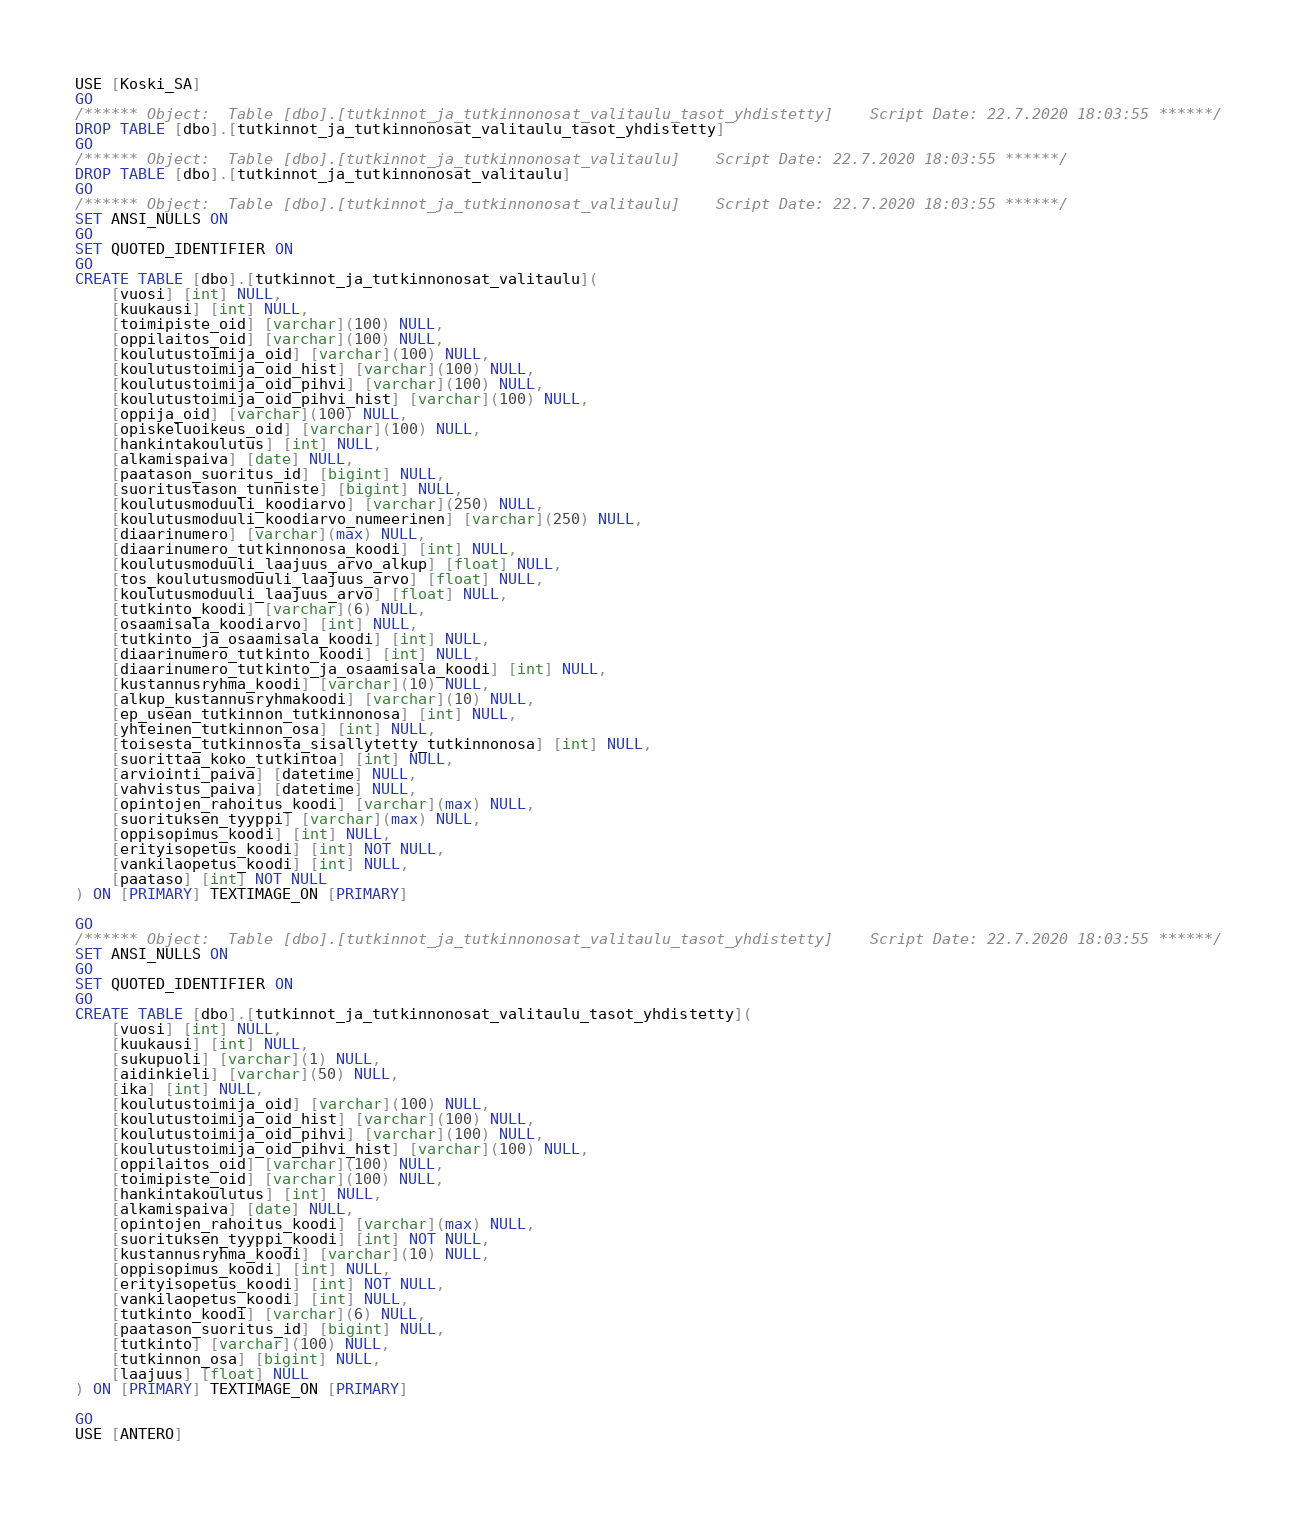Convert code to text. <code><loc_0><loc_0><loc_500><loc_500><_SQL_>USE [Koski_SA]
GO
/****** Object:  Table [dbo].[tutkinnot_ja_tutkinnonosat_valitaulu_tasot_yhdistetty]    Script Date: 22.7.2020 18:03:55 ******/
DROP TABLE [dbo].[tutkinnot_ja_tutkinnonosat_valitaulu_tasot_yhdistetty]
GO
/****** Object:  Table [dbo].[tutkinnot_ja_tutkinnonosat_valitaulu]    Script Date: 22.7.2020 18:03:55 ******/
DROP TABLE [dbo].[tutkinnot_ja_tutkinnonosat_valitaulu]
GO
/****** Object:  Table [dbo].[tutkinnot_ja_tutkinnonosat_valitaulu]    Script Date: 22.7.2020 18:03:55 ******/
SET ANSI_NULLS ON
GO
SET QUOTED_IDENTIFIER ON
GO
CREATE TABLE [dbo].[tutkinnot_ja_tutkinnonosat_valitaulu](
	[vuosi] [int] NULL,
	[kuukausi] [int] NULL,
	[toimipiste_oid] [varchar](100) NULL,
	[oppilaitos_oid] [varchar](100) NULL,
	[koulutustoimija_oid] [varchar](100) NULL,
	[koulutustoimija_oid_hist] [varchar](100) NULL,
	[koulutustoimija_oid_pihvi] [varchar](100) NULL,
	[koulutustoimija_oid_pihvi_hist] [varchar](100) NULL,
	[oppija_oid] [varchar](100) NULL,
	[opiskeluoikeus_oid] [varchar](100) NULL,
	[hankintakoulutus] [int] NULL,
	[alkamispaiva] [date] NULL,
	[paatason_suoritus_id] [bigint] NULL,
	[suoritustason_tunniste] [bigint] NULL,
	[koulutusmoduuli_koodiarvo] [varchar](250) NULL,
	[koulutusmoduuli_koodiarvo_numeerinen] [varchar](250) NULL,
	[diaarinumero] [varchar](max) NULL,
	[diaarinumero_tutkinnonosa_koodi] [int] NULL,
	[koulutusmoduuli_laajuus_arvo_alkup] [float] NULL,
	[tos_koulutusmoduuli_laajuus_arvo] [float] NULL,
	[koulutusmoduuli_laajuus_arvo] [float] NULL,
	[tutkinto_koodi] [varchar](6) NULL,
	[osaamisala_koodiarvo] [int] NULL,
	[tutkinto_ja_osaamisala_koodi] [int] NULL,
	[diaarinumero_tutkinto_koodi] [int] NULL,
	[diaarinumero_tutkinto_ja_osaamisala_koodi] [int] NULL,
	[kustannusryhma_koodi] [varchar](10) NULL,
	[alkup_kustannusryhmakoodi] [varchar](10) NULL,
	[ep_usean_tutkinnon_tutkinnonosa] [int] NULL,
	[yhteinen_tutkinnon_osa] [int] NULL,
	[toisesta_tutkinnosta_sisallytetty_tutkinnonosa] [int] NULL,
	[suorittaa_koko_tutkintoa] [int] NULL,
	[arviointi_paiva] [datetime] NULL,
	[vahvistus_paiva] [datetime] NULL,
	[opintojen_rahoitus_koodi] [varchar](max) NULL,
	[suorituksen_tyyppi] [varchar](max) NULL,
	[oppisopimus_koodi] [int] NULL,
	[erityisopetus_koodi] [int] NOT NULL,
	[vankilaopetus_koodi] [int] NULL,
	[paataso] [int] NOT NULL
) ON [PRIMARY] TEXTIMAGE_ON [PRIMARY]

GO
/****** Object:  Table [dbo].[tutkinnot_ja_tutkinnonosat_valitaulu_tasot_yhdistetty]    Script Date: 22.7.2020 18:03:55 ******/
SET ANSI_NULLS ON
GO
SET QUOTED_IDENTIFIER ON
GO
CREATE TABLE [dbo].[tutkinnot_ja_tutkinnonosat_valitaulu_tasot_yhdistetty](
	[vuosi] [int] NULL,
	[kuukausi] [int] NULL,
	[sukupuoli] [varchar](1) NULL,
	[aidinkieli] [varchar](50) NULL,
	[ika] [int] NULL,
	[koulutustoimija_oid] [varchar](100) NULL,
	[koulutustoimija_oid_hist] [varchar](100) NULL,
	[koulutustoimija_oid_pihvi] [varchar](100) NULL,
	[koulutustoimija_oid_pihvi_hist] [varchar](100) NULL,
	[oppilaitos_oid] [varchar](100) NULL,
	[toimipiste_oid] [varchar](100) NULL,
	[hankintakoulutus] [int] NULL,
	[alkamispaiva] [date] NULL,
	[opintojen_rahoitus_koodi] [varchar](max) NULL,
	[suorituksen_tyyppi_koodi] [int] NOT NULL,
	[kustannusryhma_koodi] [varchar](10) NULL,
	[oppisopimus_koodi] [int] NULL,
	[erityisopetus_koodi] [int] NOT NULL,
	[vankilaopetus_koodi] [int] NULL,
	[tutkinto_koodi] [varchar](6) NULL,
	[paatason_suoritus_id] [bigint] NULL,
	[tutkinto] [varchar](100) NULL,
	[tutkinnon_osa] [bigint] NULL,
	[laajuus] [float] NULL
) ON [PRIMARY] TEXTIMAGE_ON [PRIMARY]

GO
USE [ANTERO]</code> 